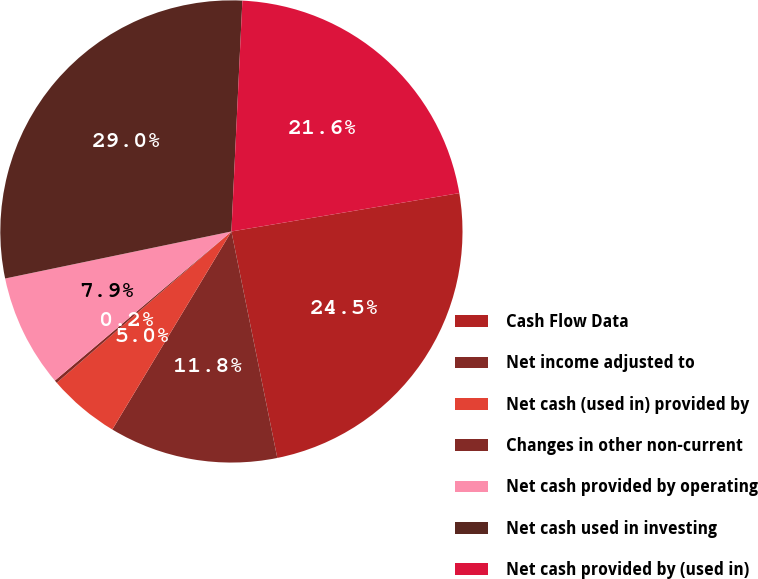Convert chart to OTSL. <chart><loc_0><loc_0><loc_500><loc_500><pie_chart><fcel>Cash Flow Data<fcel>Net income adjusted to<fcel>Net cash (used in) provided by<fcel>Changes in other non-current<fcel>Net cash provided by operating<fcel>Net cash used in investing<fcel>Net cash provided by (used in)<nl><fcel>24.47%<fcel>11.8%<fcel>5.02%<fcel>0.2%<fcel>7.9%<fcel>29.02%<fcel>21.59%<nl></chart> 